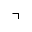<formula> <loc_0><loc_0><loc_500><loc_500>\urcorner</formula> 